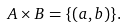Convert formula to latex. <formula><loc_0><loc_0><loc_500><loc_500>A \times B = \{ ( a , b ) \} .</formula> 